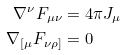<formula> <loc_0><loc_0><loc_500><loc_500>\nabla ^ { \nu } F _ { \mu \nu } & = 4 \pi J _ { \mu } \\ \nabla _ { [ \mu } F _ { \nu \rho ] } & = 0</formula> 